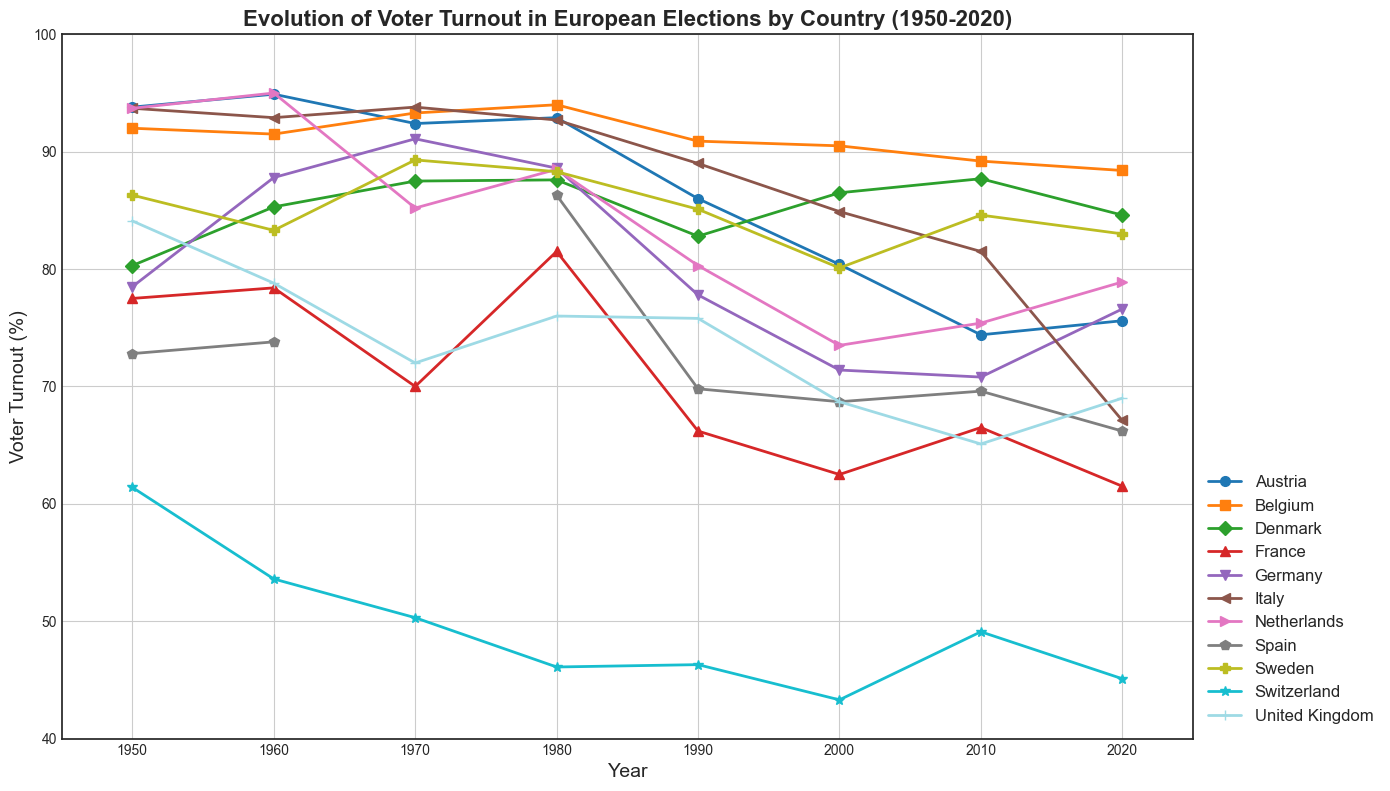What country had the highest voter turnout in 1980? Look at the plot for the year 1980 and identify the country with the highest voter turnout percentage.
Answer: Belgium Which country experienced the largest overall decline in voter turnout from 1950 to 2020? Calculate the difference in voter turnout percentage between 1950 and 2020 for each country, and identify the country with the highest decline.
Answer: Switzerland In which decade did Austria experience the most significant drop in voter turnout? Observe the plot for Austria and identify the decade with the steepest decline in voter turnout.
Answer: 1990s Between France and Germany, which country had a lower voter turnout in 1990? Compare the voter turnout percentages of France and Germany for the year 1990.
Answer: France Which country consistently maintained a relatively high voter turnout over the entire period from 1950 to 2020? Identify the country with high voter turnout percentages in almost every year throughout the period.
Answer: Belgium What was the difference in voter turnout between Italy and the Netherlands in 2020? Find the voter turnout percentages of Italy and the Netherlands in 2020 and calculate the difference.
Answer: 11.8% Which countries had voter turnouts higher than 90% in 1960? Identify the countries with voter turnout percentages greater than 90% for the year 1960.
Answer: Austria, Netherlands What is the average voter turnout in Switzerland for the timeline represented in the figure? Calculate the sum of Switzerland's voter turnout percentages for all recorded years and divide by the number of recorded data points.
Answer: Approximately 49.3% How did voter turnout in the United Kingdom change from 2000 to 2020? Compare the voter turnout percentages of the United Kingdom in 2000 and 2020 and describe the change.
Answer: Increased by 0.3% Between Belgium and Denmark, which country had a more significant increase in voter turnout from 1950 to 1960? Calculate the increase in voter turnout percentages for Belgium and Denmark from 1950 to 1960, and compare the results.
Answer: Denmark 